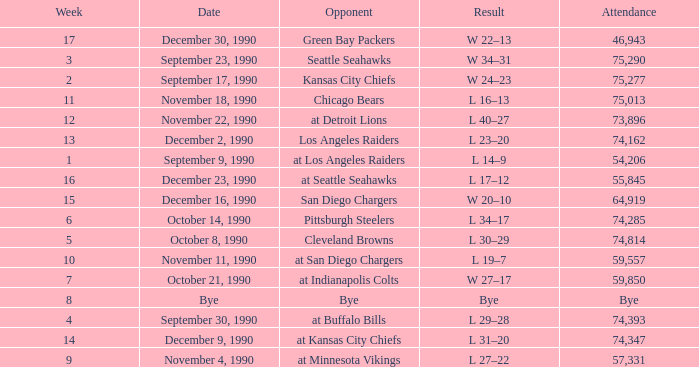What day was the attendance 74,285? October 14, 1990. 